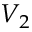Convert formula to latex. <formula><loc_0><loc_0><loc_500><loc_500>V _ { 2 }</formula> 